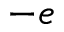<formula> <loc_0><loc_0><loc_500><loc_500>- e</formula> 